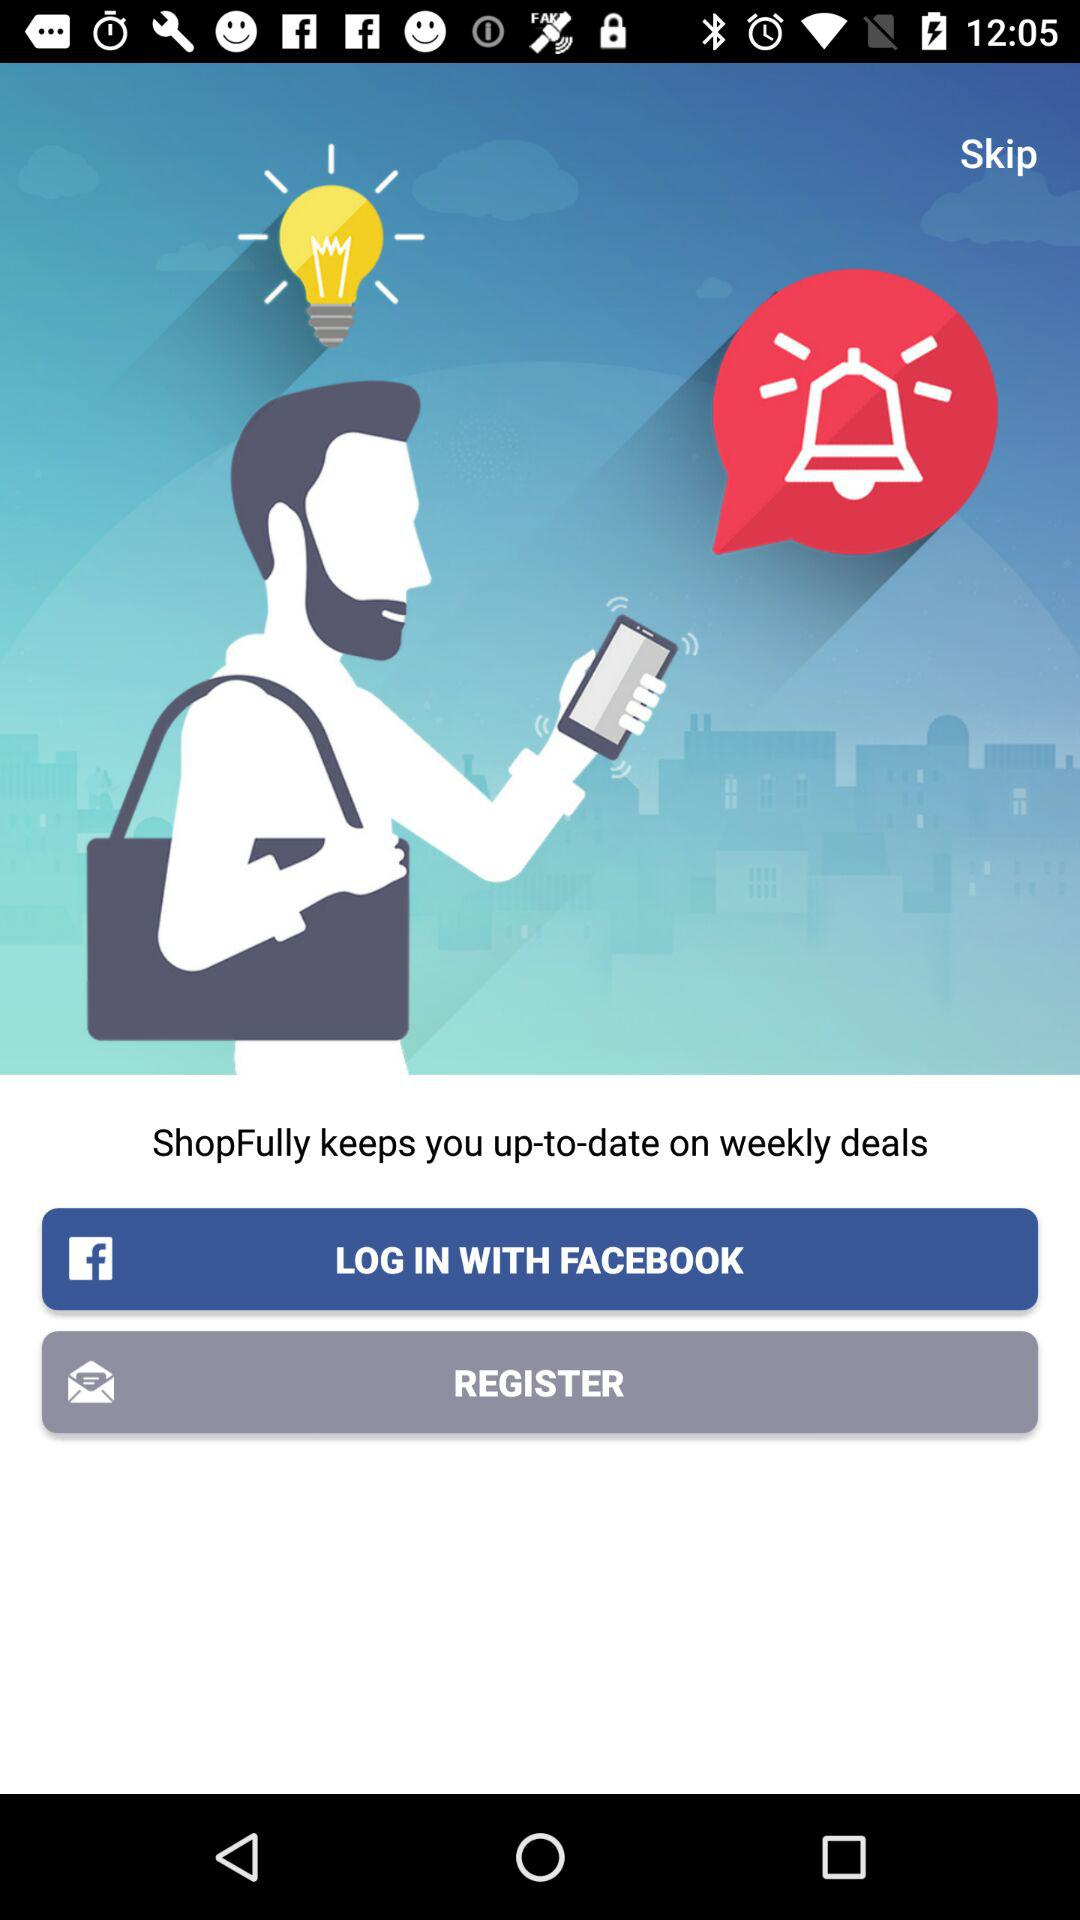Through what application can a user log in with? The application is "FACEBOOK". 